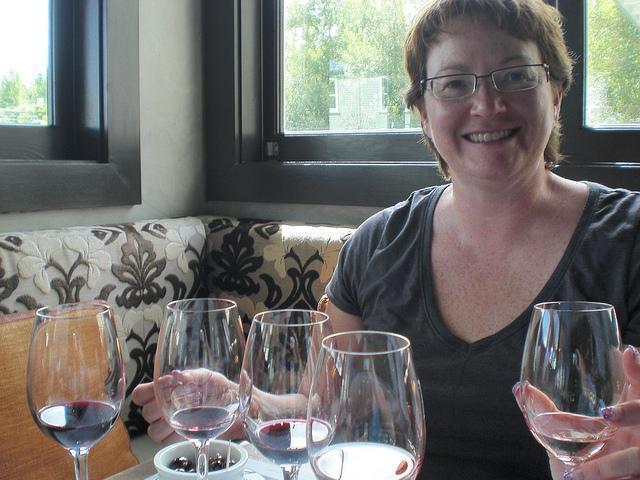How many people can be seen?
Give a very brief answer. 1. How many wine glasses are there?
Give a very brief answer. 5. 